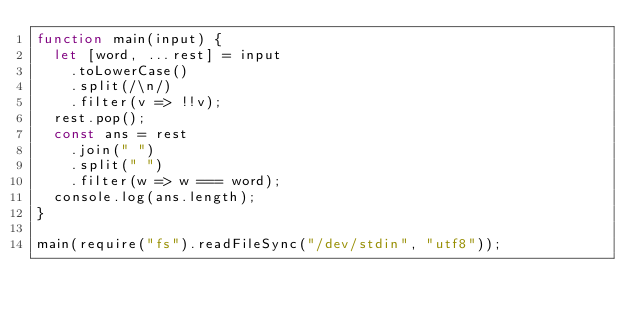<code> <loc_0><loc_0><loc_500><loc_500><_JavaScript_>function main(input) {
  let [word, ...rest] = input
    .toLowerCase()
    .split(/\n/)
    .filter(v => !!v);
  rest.pop();
  const ans = rest
    .join(" ")
    .split(" ")
    .filter(w => w === word);
  console.log(ans.length);
}

main(require("fs").readFileSync("/dev/stdin", "utf8"));

</code> 